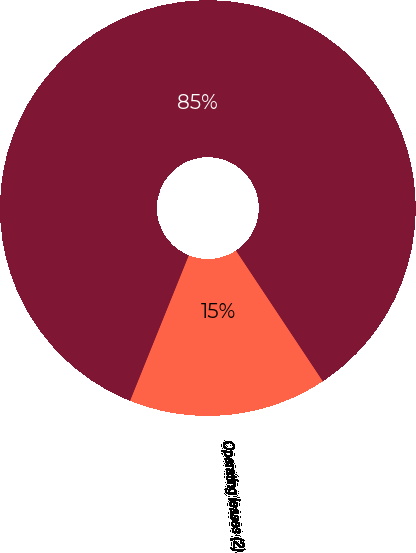<chart> <loc_0><loc_0><loc_500><loc_500><pie_chart><fcel>Operating leases (2)<fcel>Total<nl><fcel>15.44%<fcel>84.56%<nl></chart> 